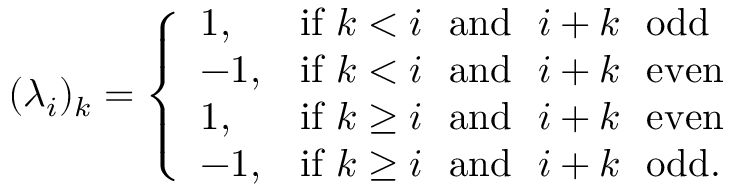<formula> <loc_0><loc_0><loc_500><loc_500>( \lambda _ { i } ) _ { k } = \left \{ \begin{array} { l l } { 1 , } & { i f k < i \ a n d \ i + k \ o d d } \\ { - 1 , } & { i f k < i \ a n d \ i + k \ e v e n } \\ { 1 , } & { i f k \geq i \ a n d \ i + k \ e v e n } \\ { - 1 , } & { i f k \geq i \ a n d \ i + k \ o d d . } \end{array}</formula> 